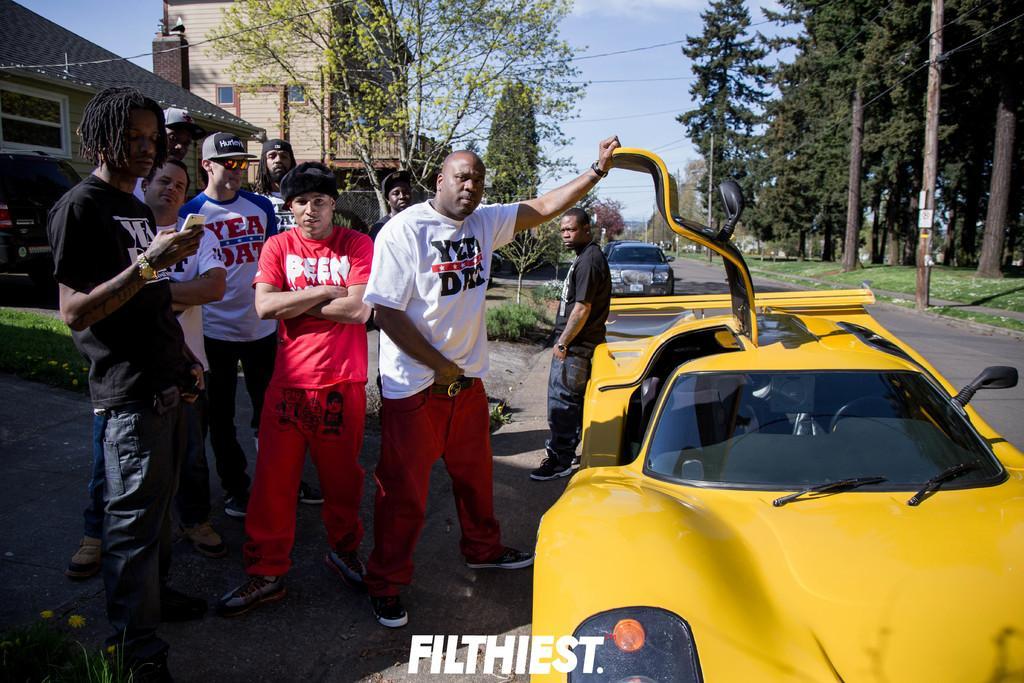Please provide a concise description of this image. In this image we can see a group of persons. On the left side, we can see a person holding a mobile. Beside the persons we can see a car. Behind the persons we can see buildings, plants, trees and a vehicle. In the top right, we can see trees, grass and a pole with wires. At the top we can see the sky and the wires. 